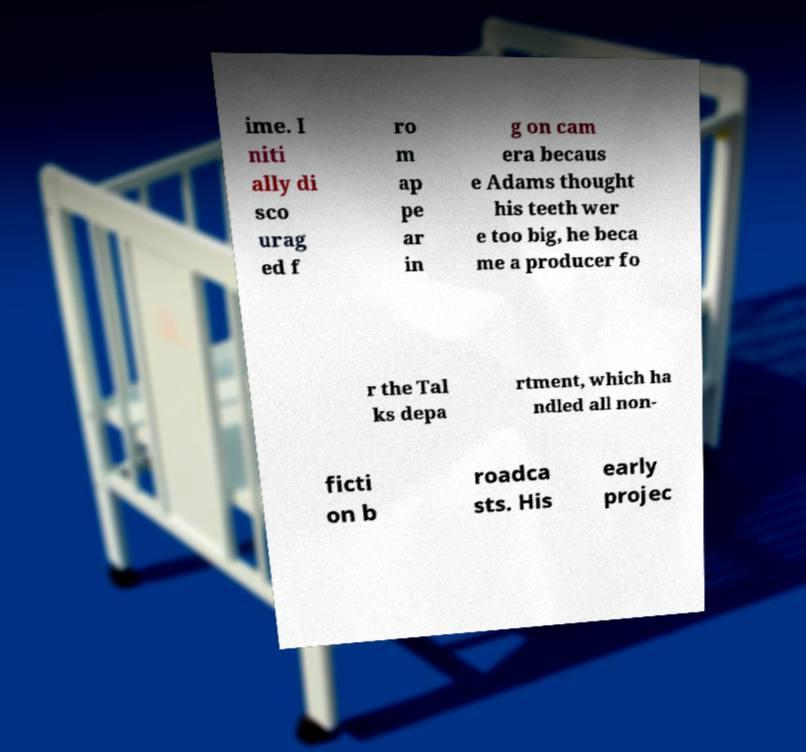I need the written content from this picture converted into text. Can you do that? ime. I niti ally di sco urag ed f ro m ap pe ar in g on cam era becaus e Adams thought his teeth wer e too big, he beca me a producer fo r the Tal ks depa rtment, which ha ndled all non- ficti on b roadca sts. His early projec 